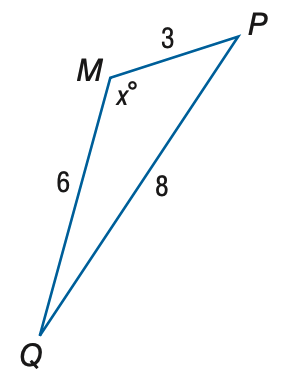Question: Find x. Round to the nearest degree.
Choices:
A. 102
B. 112
C. 122
D. 132
Answer with the letter. Answer: C 